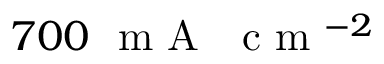<formula> <loc_0><loc_0><loc_500><loc_500>7 0 0 m A c m ^ { - 2 }</formula> 